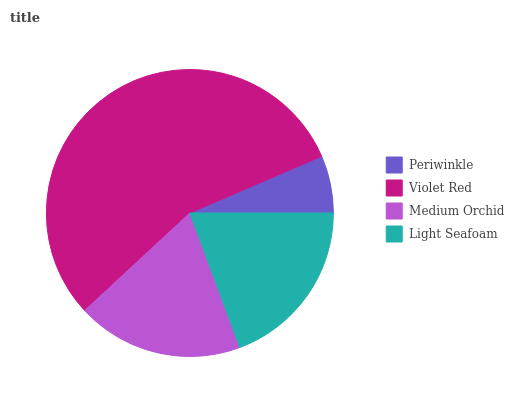Is Periwinkle the minimum?
Answer yes or no. Yes. Is Violet Red the maximum?
Answer yes or no. Yes. Is Medium Orchid the minimum?
Answer yes or no. No. Is Medium Orchid the maximum?
Answer yes or no. No. Is Violet Red greater than Medium Orchid?
Answer yes or no. Yes. Is Medium Orchid less than Violet Red?
Answer yes or no. Yes. Is Medium Orchid greater than Violet Red?
Answer yes or no. No. Is Violet Red less than Medium Orchid?
Answer yes or no. No. Is Light Seafoam the high median?
Answer yes or no. Yes. Is Medium Orchid the low median?
Answer yes or no. Yes. Is Periwinkle the high median?
Answer yes or no. No. Is Violet Red the low median?
Answer yes or no. No. 